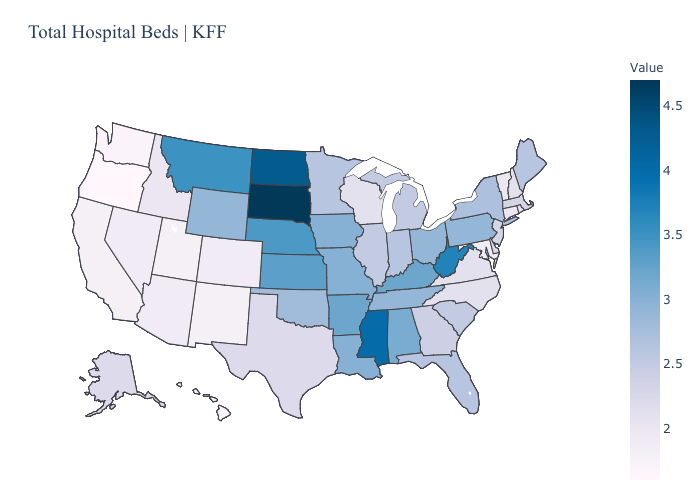Which states have the lowest value in the Northeast?
Write a very short answer. Connecticut, Vermont. Which states have the lowest value in the MidWest?
Give a very brief answer. Wisconsin. Which states have the lowest value in the South?
Answer briefly. Maryland. Does Vermont have the lowest value in the Northeast?
Keep it brief. Yes. Among the states that border Oregon , which have the highest value?
Give a very brief answer. Idaho. Does Minnesota have a higher value than West Virginia?
Answer briefly. No. Which states have the lowest value in the USA?
Quick response, please. Oregon. 